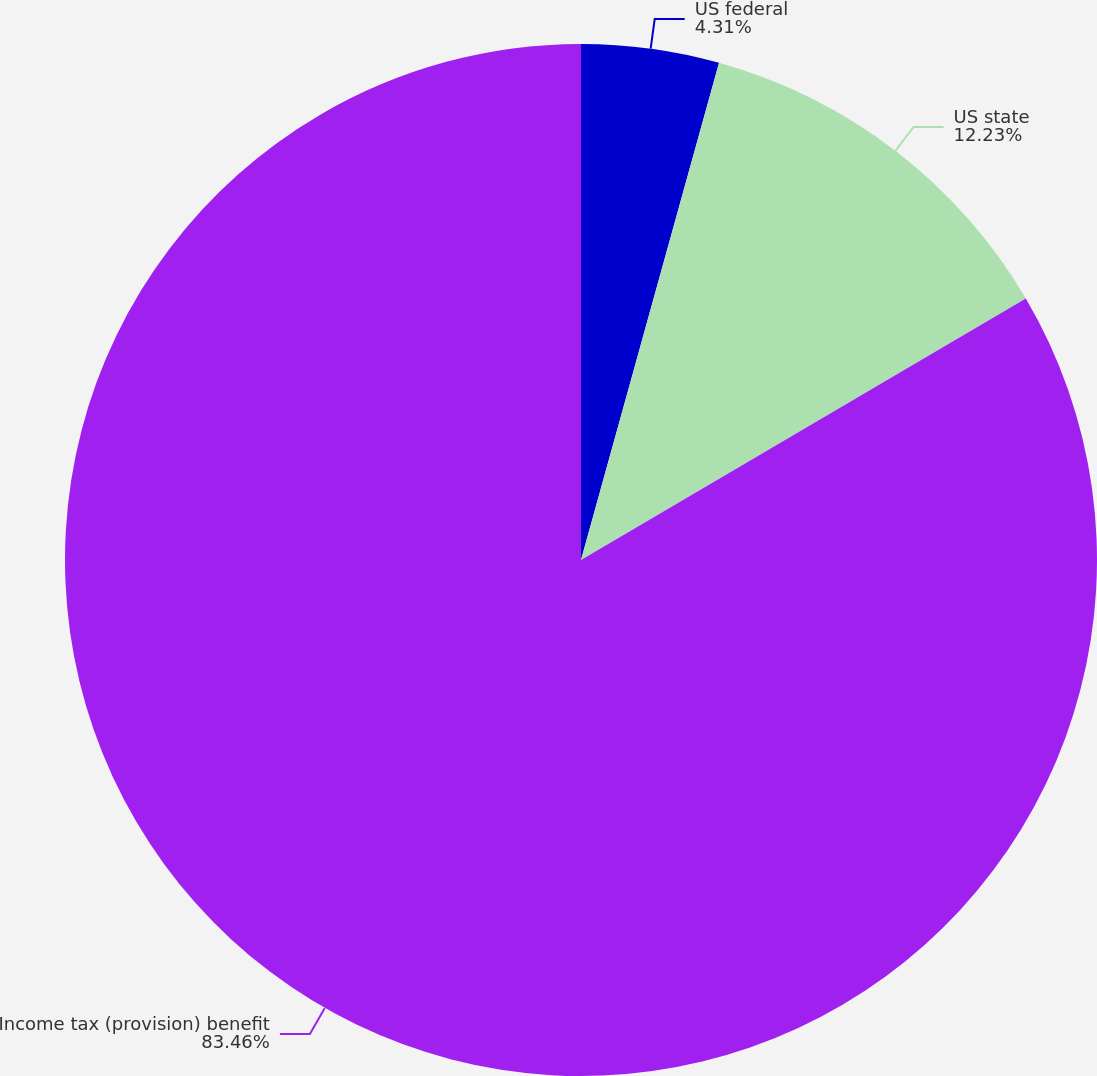Convert chart. <chart><loc_0><loc_0><loc_500><loc_500><pie_chart><fcel>US federal<fcel>US state<fcel>Income tax (provision) benefit<nl><fcel>4.31%<fcel>12.23%<fcel>83.46%<nl></chart> 